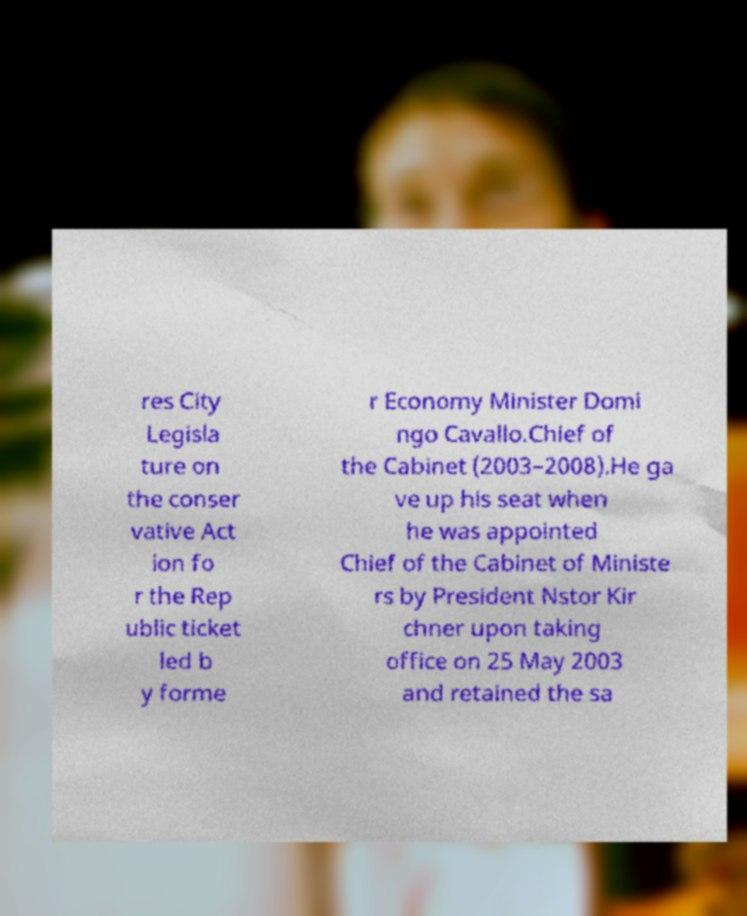Please read and relay the text visible in this image. What does it say? res City Legisla ture on the conser vative Act ion fo r the Rep ublic ticket led b y forme r Economy Minister Domi ngo Cavallo.Chief of the Cabinet (2003–2008).He ga ve up his seat when he was appointed Chief of the Cabinet of Ministe rs by President Nstor Kir chner upon taking office on 25 May 2003 and retained the sa 